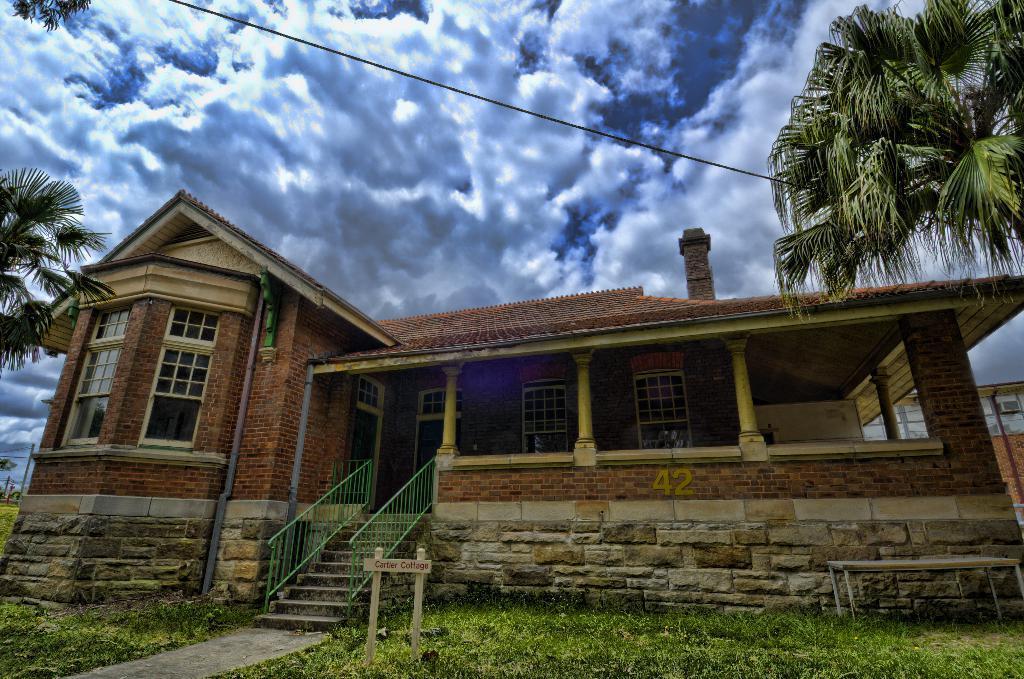Describe this image in one or two sentences. At the bottom of the image on the ground there is grass and also there is a table and wooden sign board. In the image there is a house with roofs, walls, poles, pillars, glass windows and chimney. At the top of the image there is sky with clouds and also there are trees and wires. 